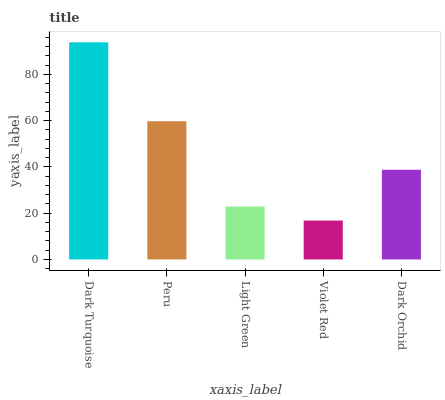Is Violet Red the minimum?
Answer yes or no. Yes. Is Dark Turquoise the maximum?
Answer yes or no. Yes. Is Peru the minimum?
Answer yes or no. No. Is Peru the maximum?
Answer yes or no. No. Is Dark Turquoise greater than Peru?
Answer yes or no. Yes. Is Peru less than Dark Turquoise?
Answer yes or no. Yes. Is Peru greater than Dark Turquoise?
Answer yes or no. No. Is Dark Turquoise less than Peru?
Answer yes or no. No. Is Dark Orchid the high median?
Answer yes or no. Yes. Is Dark Orchid the low median?
Answer yes or no. Yes. Is Light Green the high median?
Answer yes or no. No. Is Violet Red the low median?
Answer yes or no. No. 